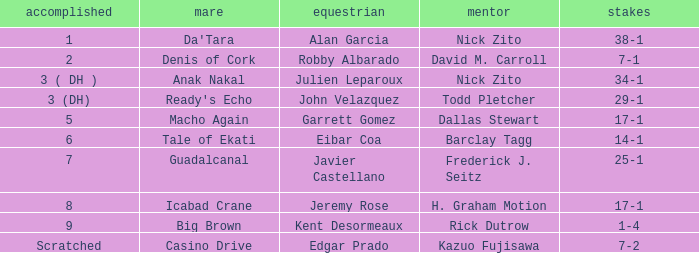What is the Finished place for da'tara trained by Nick zito? 1.0. 